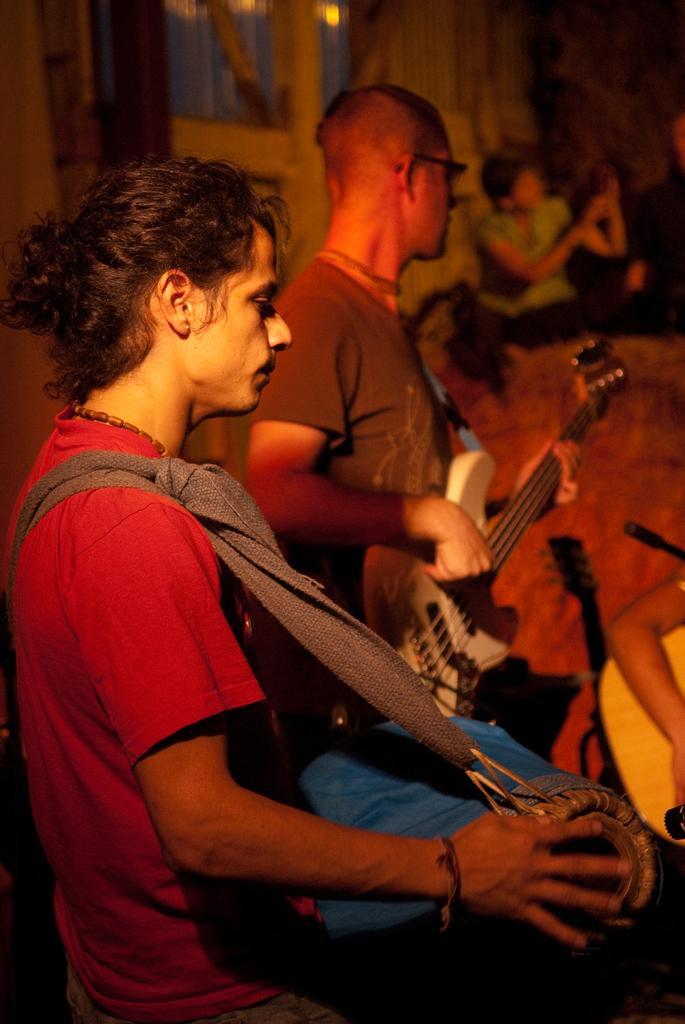Please provide a concise description of this image. this is a picture in side of a home. And there are the persons holding musical instruments like drum and violin 